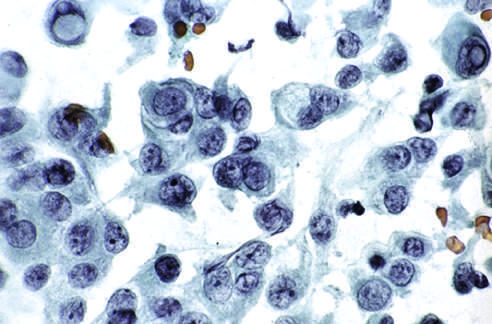how are characteristic intranuclear inclusions?
Answer the question using a single word or phrase. Visible in some of the aspirated cells 